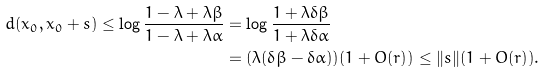<formula> <loc_0><loc_0><loc_500><loc_500>d ( x _ { 0 } , x _ { 0 } + s ) \leq \log \frac { 1 - \lambda + \lambda \beta } { 1 - \lambda + \lambda \alpha } & = \log \frac { 1 + \lambda \delta \beta } { 1 + \lambda \delta \alpha } \\ & = ( \lambda ( \delta \beta - \delta \alpha ) ) ( 1 + O ( r ) ) \leq \| s \| ( 1 + O ( r ) ) .</formula> 